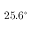Convert formula to latex. <formula><loc_0><loc_0><loc_500><loc_500>2 5 . 6 ^ { \circ }</formula> 